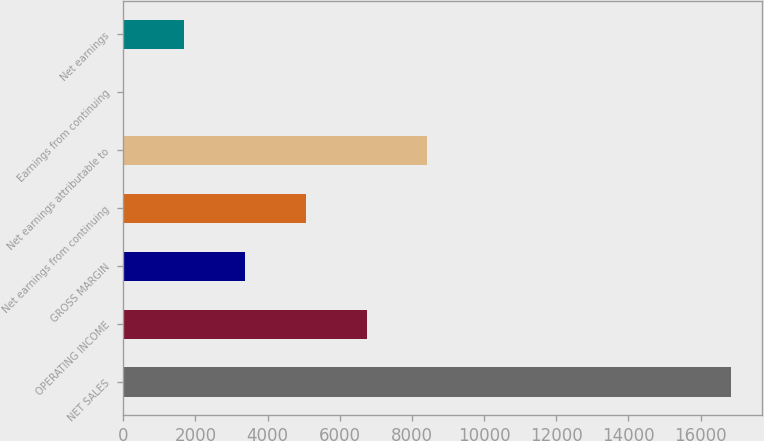<chart> <loc_0><loc_0><loc_500><loc_500><bar_chart><fcel>NET SALES<fcel>OPERATING INCOME<fcel>GROSS MARGIN<fcel>Net earnings from continuing<fcel>Net earnings attributable to<fcel>Earnings from continuing<fcel>Net earnings<nl><fcel>16856<fcel>6742.97<fcel>3371.95<fcel>5057.46<fcel>8428.48<fcel>0.93<fcel>1686.44<nl></chart> 